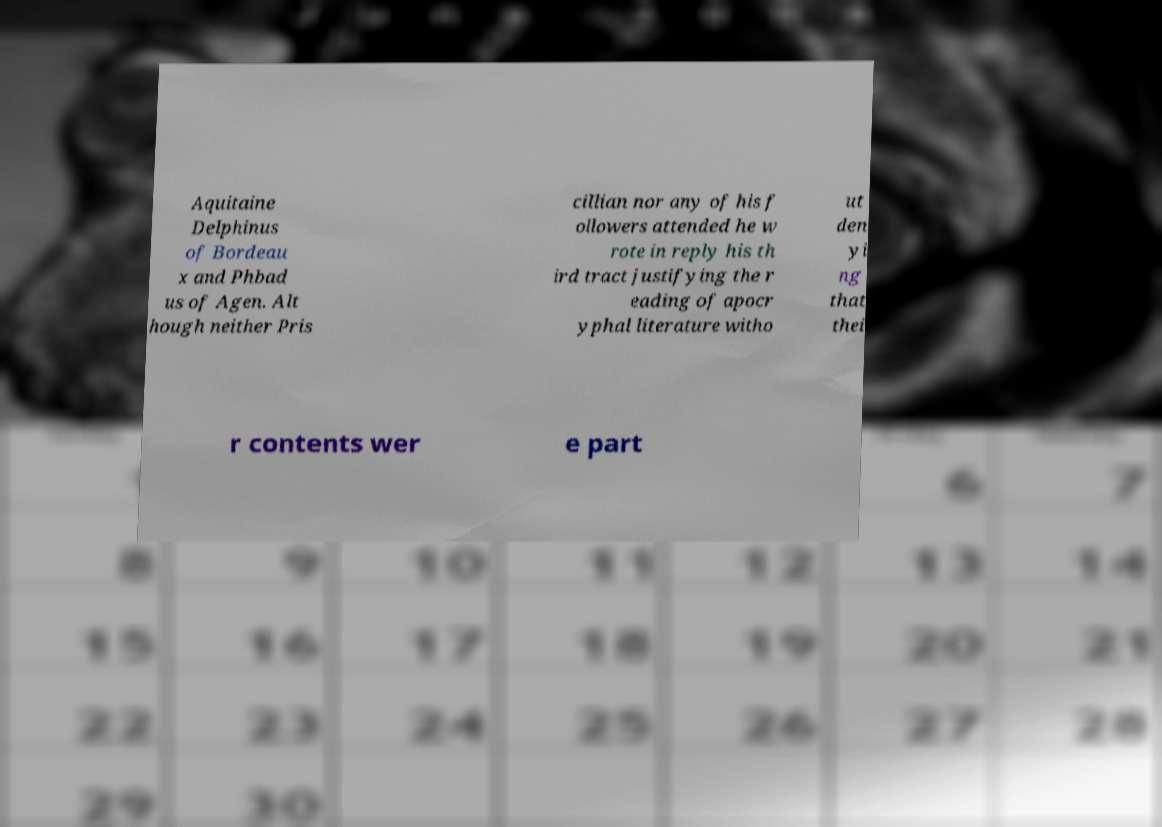What messages or text are displayed in this image? I need them in a readable, typed format. Aquitaine Delphinus of Bordeau x and Phbad us of Agen. Alt hough neither Pris cillian nor any of his f ollowers attended he w rote in reply his th ird tract justifying the r eading of apocr yphal literature witho ut den yi ng that thei r contents wer e part 